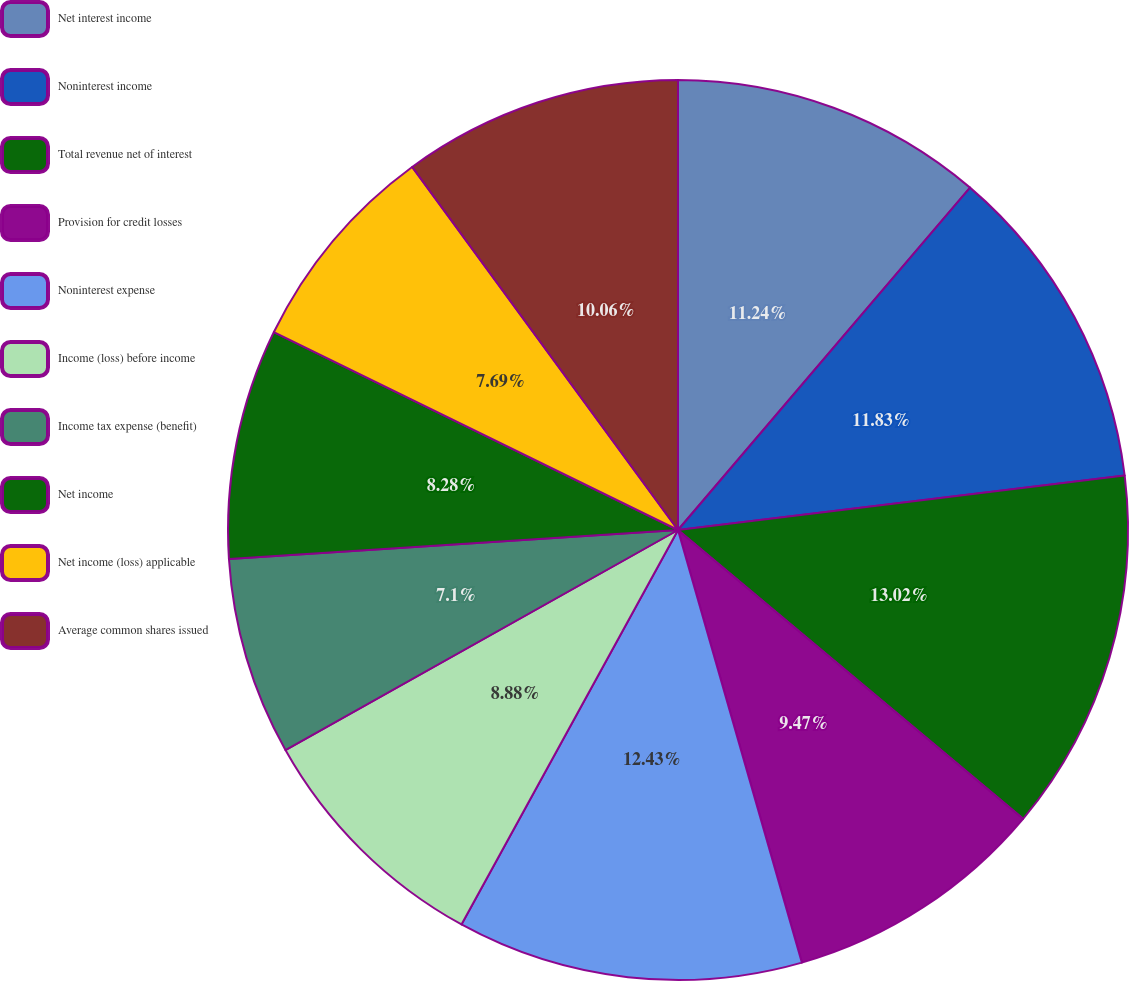<chart> <loc_0><loc_0><loc_500><loc_500><pie_chart><fcel>Net interest income<fcel>Noninterest income<fcel>Total revenue net of interest<fcel>Provision for credit losses<fcel>Noninterest expense<fcel>Income (loss) before income<fcel>Income tax expense (benefit)<fcel>Net income<fcel>Net income (loss) applicable<fcel>Average common shares issued<nl><fcel>11.24%<fcel>11.83%<fcel>13.02%<fcel>9.47%<fcel>12.43%<fcel>8.88%<fcel>7.1%<fcel>8.28%<fcel>7.69%<fcel>10.06%<nl></chart> 